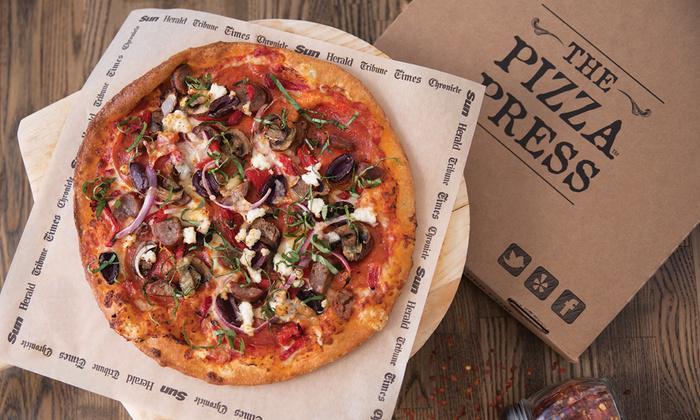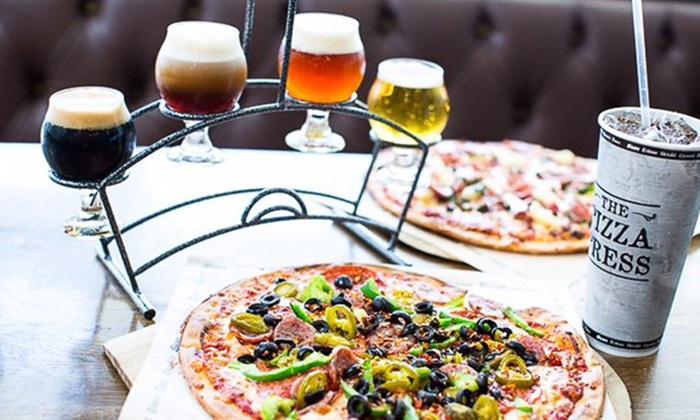The first image is the image on the left, the second image is the image on the right. Examine the images to the left and right. Is the description "At least one of the drinks is in a paper cup." accurate? Answer yes or no. Yes. The first image is the image on the left, the second image is the image on the right. Analyze the images presented: Is the assertion "In the image on the right, the pizza is placed next to a salad." valid? Answer yes or no. No. 